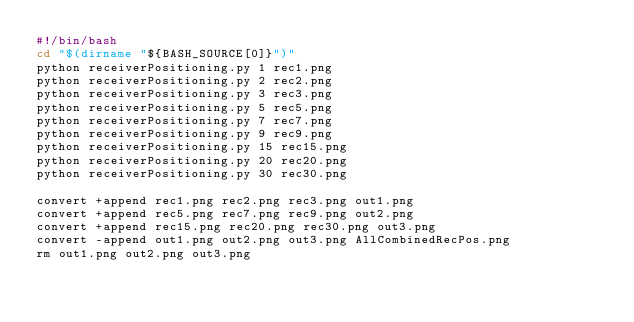Convert code to text. <code><loc_0><loc_0><loc_500><loc_500><_Bash_>#!/bin/bash
cd "$(dirname "${BASH_SOURCE[0]}")"
python receiverPositioning.py 1 rec1.png
python receiverPositioning.py 2 rec2.png
python receiverPositioning.py 3 rec3.png
python receiverPositioning.py 5 rec5.png
python receiverPositioning.py 7 rec7.png
python receiverPositioning.py 9 rec9.png
python receiverPositioning.py 15 rec15.png
python receiverPositioning.py 20 rec20.png
python receiverPositioning.py 30 rec30.png

convert +append rec1.png rec2.png rec3.png out1.png
convert +append rec5.png rec7.png rec9.png out2.png
convert +append rec15.png rec20.png rec30.png out3.png
convert -append out1.png out2.png out3.png AllCombinedRecPos.png
rm out1.png out2.png out3.png
</code> 